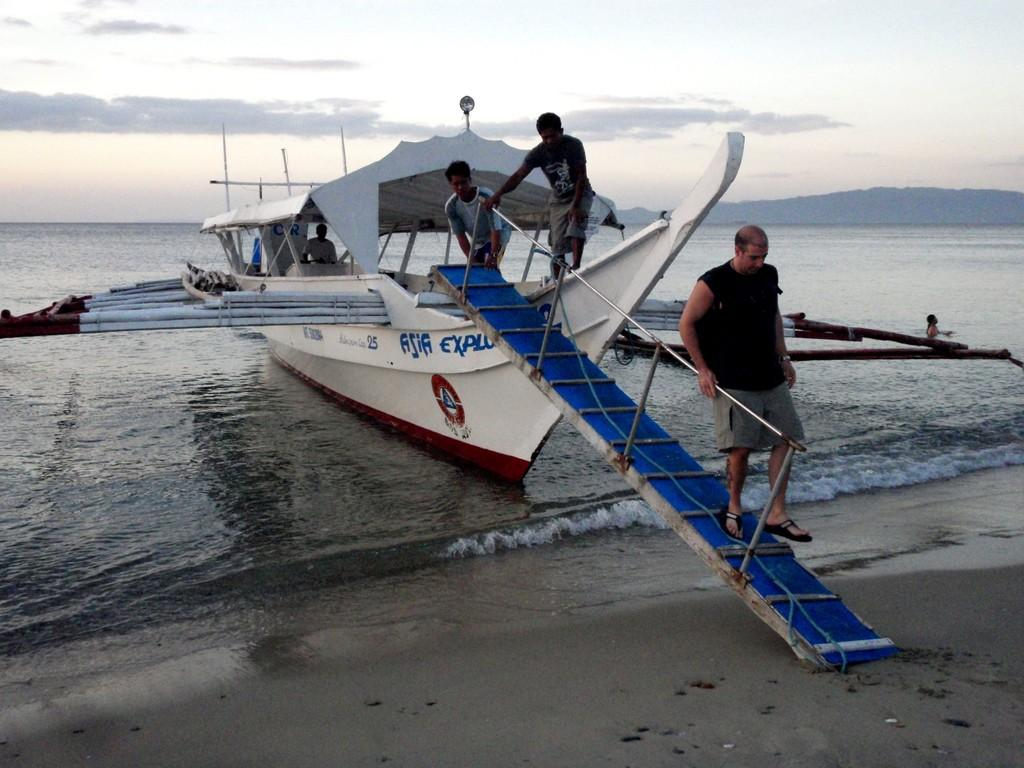What is present in the image that is related to water? There is water in the image. What can be seen floating on the water in the image? There is a boat in the image. image. Are there any people visible in the image? Yes, there are people in the image. What architectural feature can be seen in the image? There are stairs in the image. What is visible in the background of the image? The sky is visible in the image, and there are clouds in the sky. What type of tub is visible in the image? There is no tub present in the image. How does the visitor interact with the boat in the image? There is no visitor mentioned in the image, and therefore no interaction with the boat can be observed. 